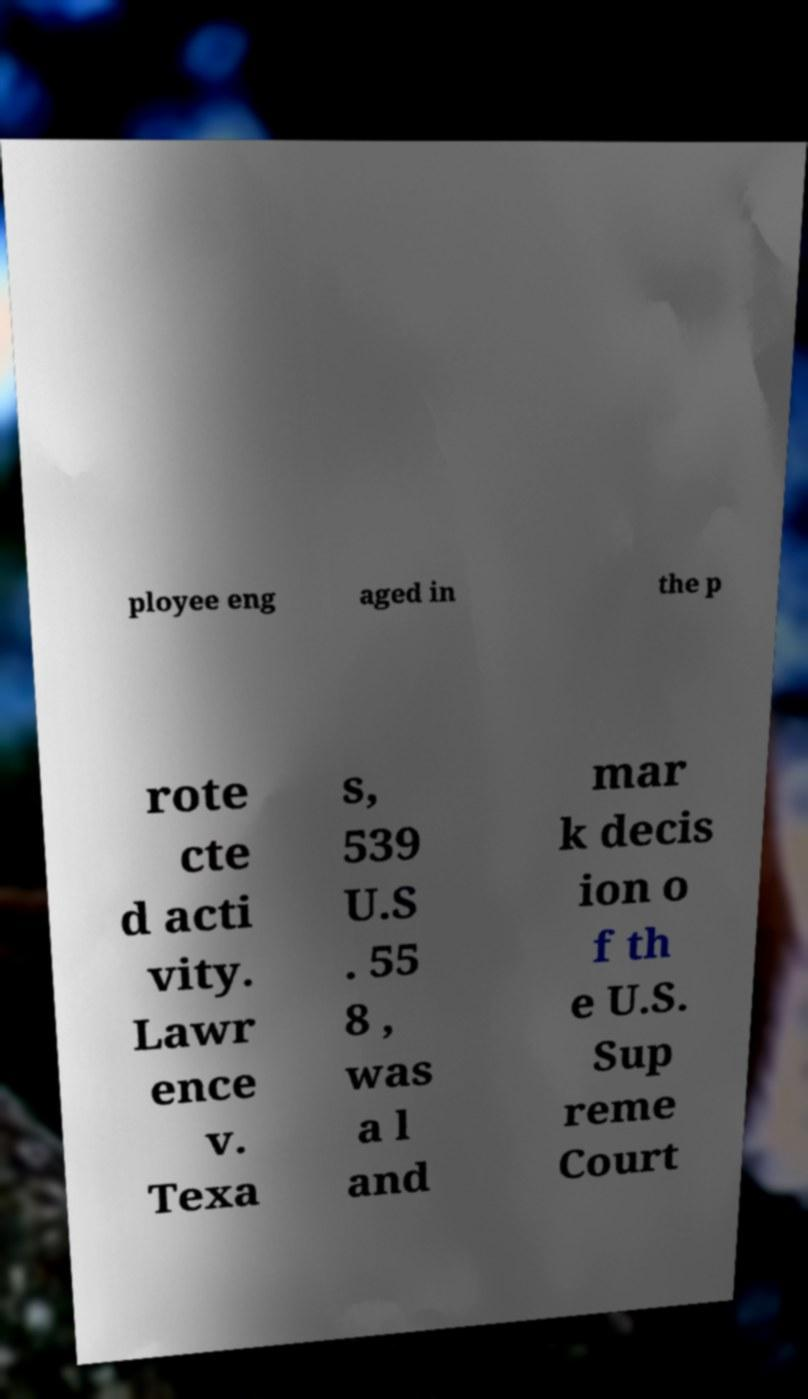I need the written content from this picture converted into text. Can you do that? ployee eng aged in the p rote cte d acti vity. Lawr ence v. Texa s, 539 U.S . 55 8 , was a l and mar k decis ion o f th e U.S. Sup reme Court 